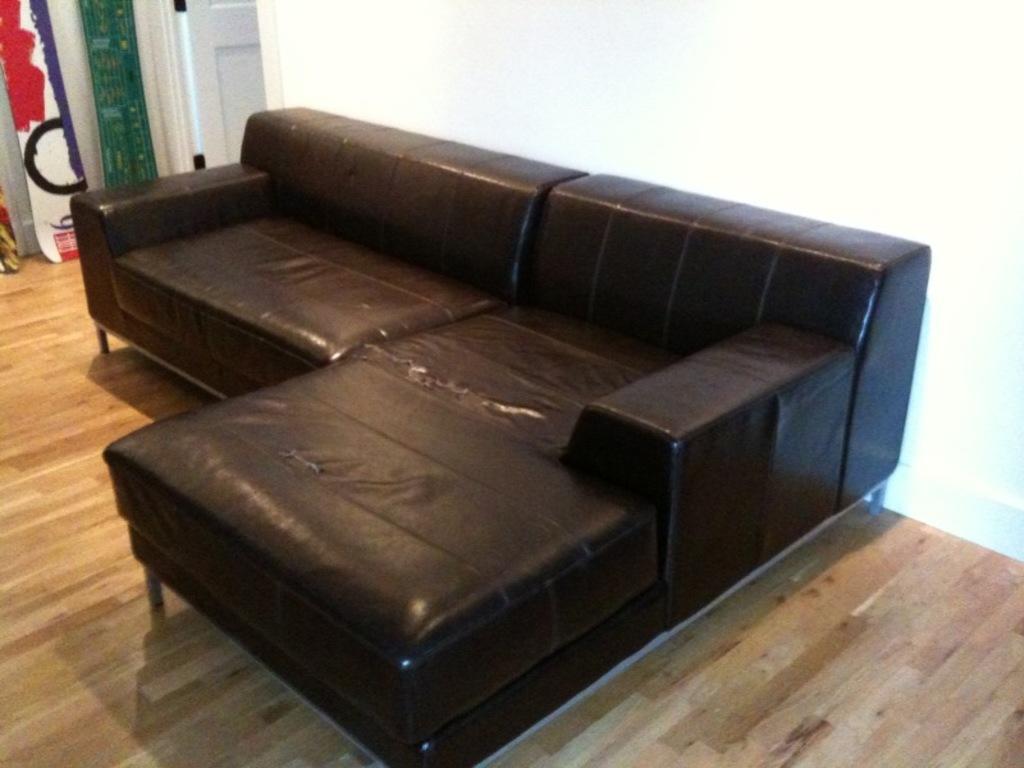Please provide a concise description of this image. This image is clicked inside the room. In the center there is a black colour sofa. At the right side there is a white colour door. In the background grey colour curtain and multi color curtain. 